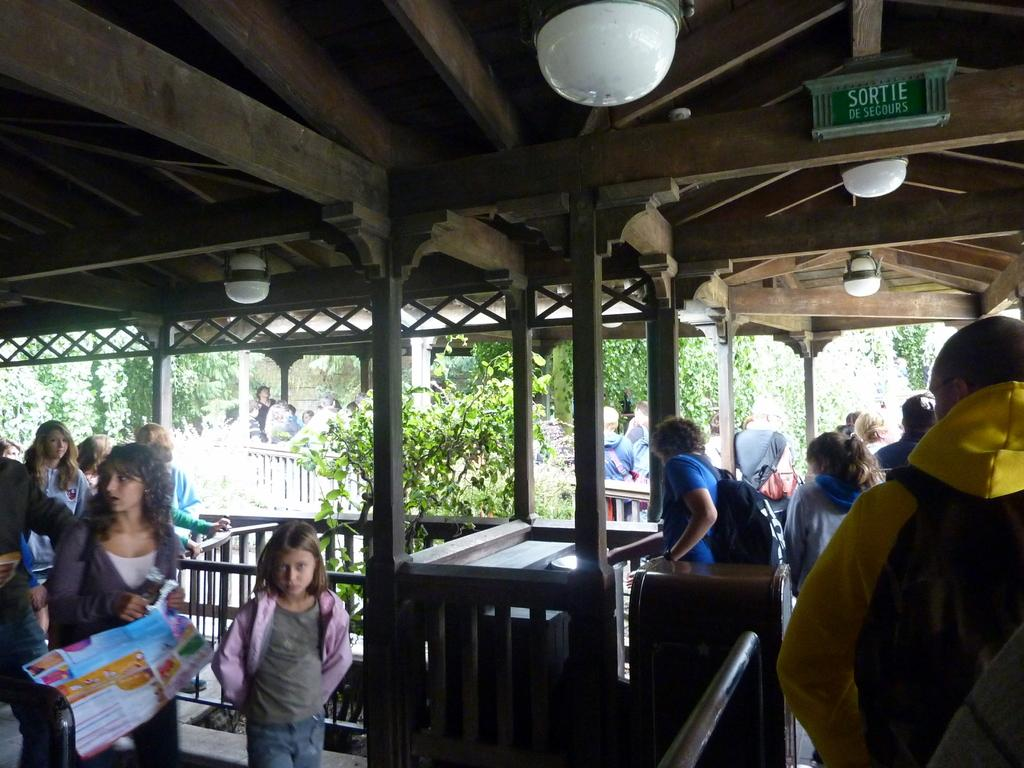What are the people in the image wearing? The persons in the image are wearing clothes. What can be seen on the ceiling in the image? There are lights on the ceiling in the image. What type of natural elements are present in the image? There are trees in the middle of the image. What type of vegetable is being used as a support for the elbow in the image? There is no vegetable or elbow present in the image. 